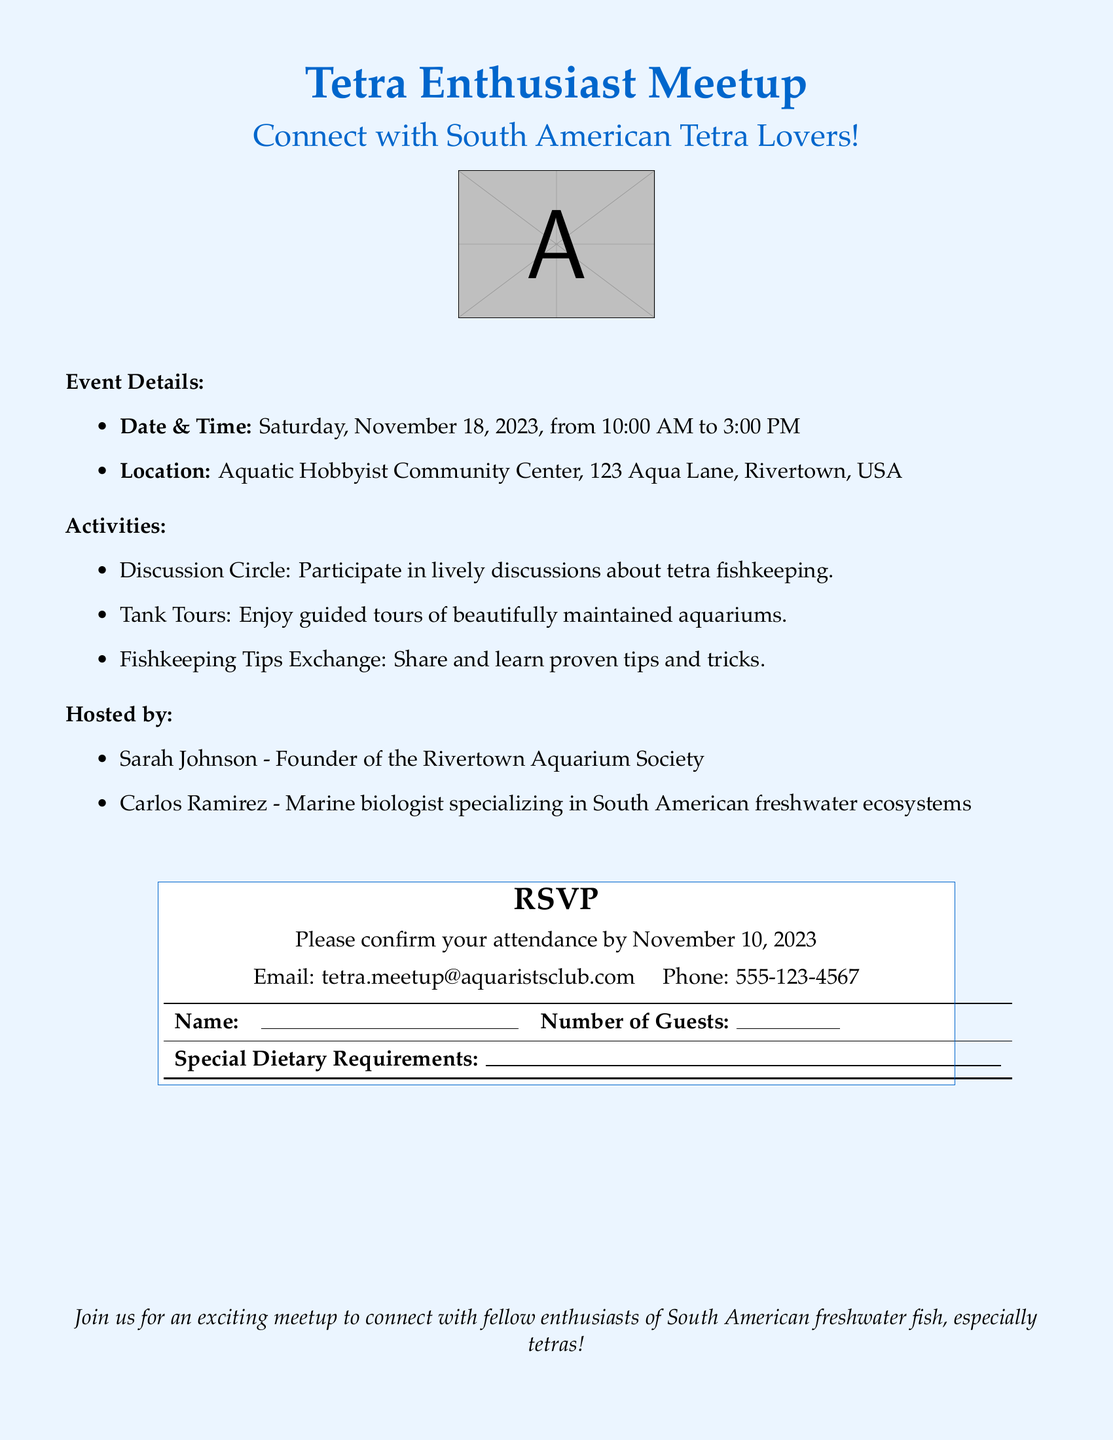What is the date of the event? The date of the event is mentioned directly in the document as Saturday, November 18, 2023.
Answer: November 18, 2023 What time does the event start? The starting time of the event is listed in the details section as 10:00 AM.
Answer: 10:00 AM Who is one of the hosts of the meetup? The document lists Sarah Johnson as one of the hosts in the hosting section.
Answer: Sarah Johnson What activities are mentioned in the document? The document includes several activities such as Discussion Circle, Tank Tours, and Fishkeeping Tips Exchange.
Answer: Discussion Circle, Tank Tours, Fishkeeping Tips Exchange What is the RSVP deadline? The document explicitly mentions that attendees should confirm their attendance by November 10, 2023.
Answer: November 10, 2023 How can participants contact for RSVP? The document provides two methods of contact: email and phone, specifically mentioning tetra.meetup@aquaristsclub.com and 555-123-4567.
Answer: tetra.meetup@aquaristsclub.com What is the location of the event? The location is specified in the document as Aquatic Hobbyist Community Center, 123 Aqua Lane, Rivertown, USA.
Answer: Aquatic Hobbyist Community Center, 123 Aqua Lane, Rivertown, USA What type of event is this document for? The document specifically indicates that it is for a Tetra Enthusiast Meetup.
Answer: Tetra Enthusiast Meetup 